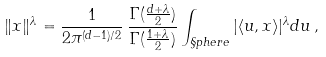<formula> <loc_0><loc_0><loc_500><loc_500>\| x \| ^ { \lambda } = \frac { 1 } { 2 \pi ^ { ( d - 1 ) / 2 } } \, \frac { \Gamma ( \frac { d + \lambda } { 2 } ) } { \Gamma ( \frac { 1 + \lambda } { 2 } ) } \int _ { \S p h e r e } | \langle u , x \rangle | ^ { \lambda } d u \, ,</formula> 